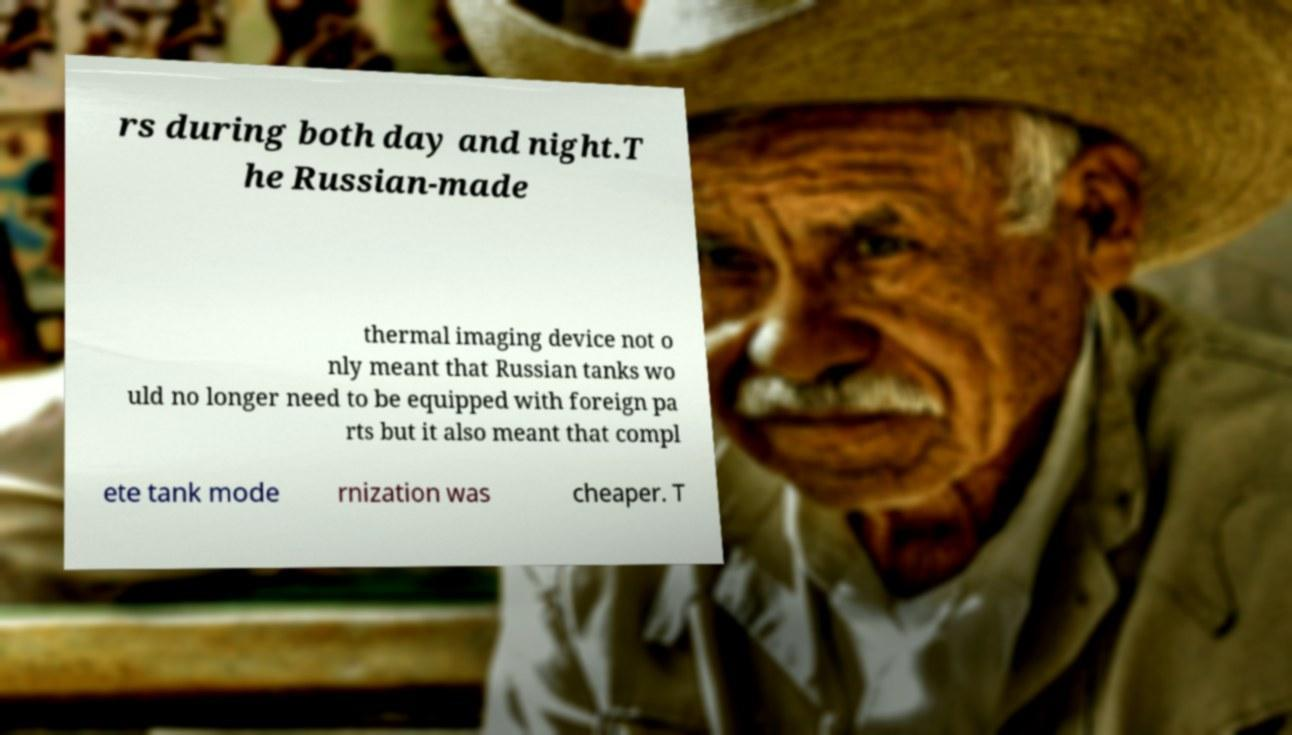I need the written content from this picture converted into text. Can you do that? rs during both day and night.T he Russian-made thermal imaging device not o nly meant that Russian tanks wo uld no longer need to be equipped with foreign pa rts but it also meant that compl ete tank mode rnization was cheaper. T 